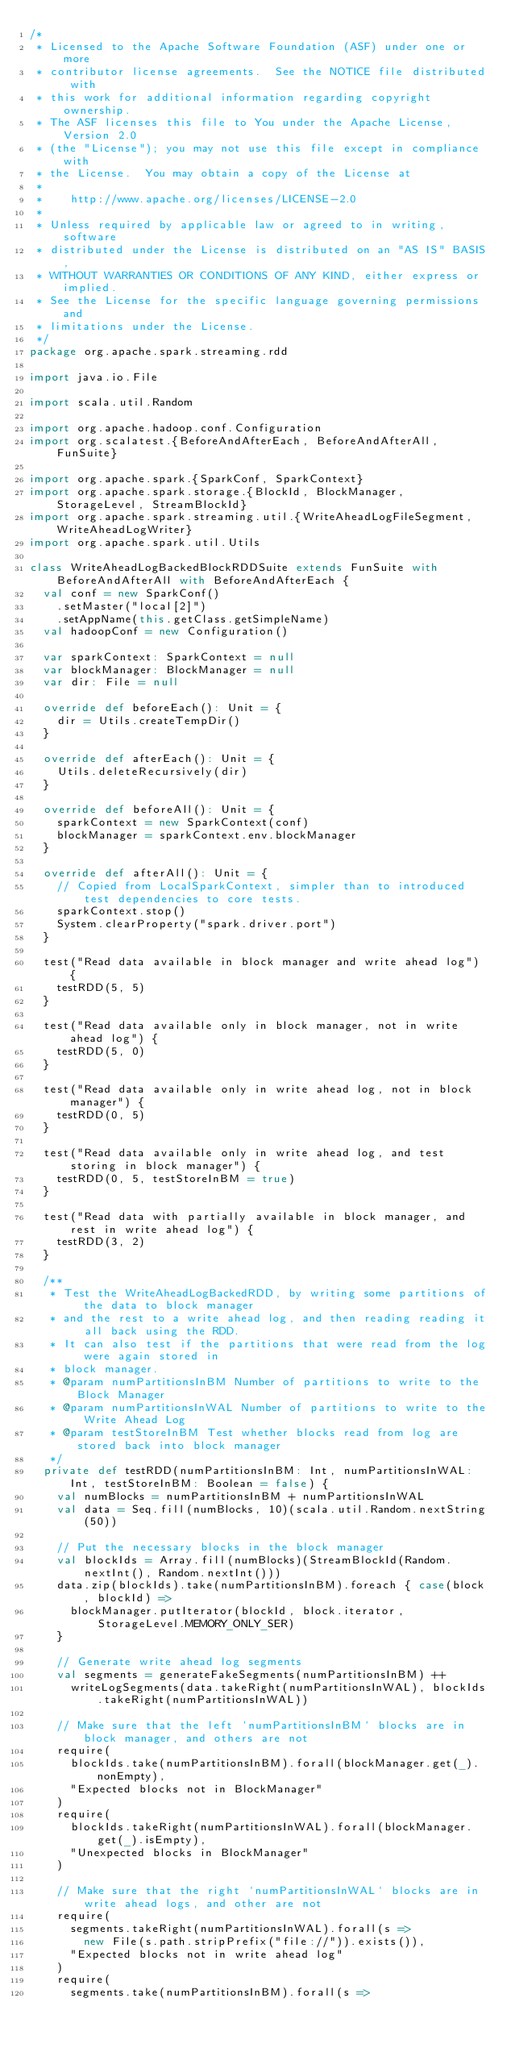Convert code to text. <code><loc_0><loc_0><loc_500><loc_500><_Scala_>/*
 * Licensed to the Apache Software Foundation (ASF) under one or more
 * contributor license agreements.  See the NOTICE file distributed with
 * this work for additional information regarding copyright ownership.
 * The ASF licenses this file to You under the Apache License, Version 2.0
 * (the "License"); you may not use this file except in compliance with
 * the License.  You may obtain a copy of the License at
 *
 *    http://www.apache.org/licenses/LICENSE-2.0
 *
 * Unless required by applicable law or agreed to in writing, software
 * distributed under the License is distributed on an "AS IS" BASIS,
 * WITHOUT WARRANTIES OR CONDITIONS OF ANY KIND, either express or implied.
 * See the License for the specific language governing permissions and
 * limitations under the License.
 */
package org.apache.spark.streaming.rdd

import java.io.File

import scala.util.Random

import org.apache.hadoop.conf.Configuration
import org.scalatest.{BeforeAndAfterEach, BeforeAndAfterAll, FunSuite}

import org.apache.spark.{SparkConf, SparkContext}
import org.apache.spark.storage.{BlockId, BlockManager, StorageLevel, StreamBlockId}
import org.apache.spark.streaming.util.{WriteAheadLogFileSegment, WriteAheadLogWriter}
import org.apache.spark.util.Utils

class WriteAheadLogBackedBlockRDDSuite extends FunSuite with BeforeAndAfterAll with BeforeAndAfterEach {
  val conf = new SparkConf()
    .setMaster("local[2]")
    .setAppName(this.getClass.getSimpleName)
  val hadoopConf = new Configuration()

  var sparkContext: SparkContext = null
  var blockManager: BlockManager = null
  var dir: File = null

  override def beforeEach(): Unit = {
    dir = Utils.createTempDir()
  }

  override def afterEach(): Unit = {
    Utils.deleteRecursively(dir)
  }

  override def beforeAll(): Unit = {
    sparkContext = new SparkContext(conf)
    blockManager = sparkContext.env.blockManager
  }

  override def afterAll(): Unit = {
    // Copied from LocalSparkContext, simpler than to introduced test dependencies to core tests.
    sparkContext.stop()
    System.clearProperty("spark.driver.port")
  }

  test("Read data available in block manager and write ahead log") {
    testRDD(5, 5)
  }

  test("Read data available only in block manager, not in write ahead log") {
    testRDD(5, 0)
  }

  test("Read data available only in write ahead log, not in block manager") {
    testRDD(0, 5)
  }

  test("Read data available only in write ahead log, and test storing in block manager") {
    testRDD(0, 5, testStoreInBM = true)
  }

  test("Read data with partially available in block manager, and rest in write ahead log") {
    testRDD(3, 2)
  }

  /**
   * Test the WriteAheadLogBackedRDD, by writing some partitions of the data to block manager
   * and the rest to a write ahead log, and then reading reading it all back using the RDD.
   * It can also test if the partitions that were read from the log were again stored in
   * block manager.
   * @param numPartitionsInBM Number of partitions to write to the Block Manager
   * @param numPartitionsInWAL Number of partitions to write to the Write Ahead Log
   * @param testStoreInBM Test whether blocks read from log are stored back into block manager
   */
  private def testRDD(numPartitionsInBM: Int, numPartitionsInWAL: Int, testStoreInBM: Boolean = false) {
    val numBlocks = numPartitionsInBM + numPartitionsInWAL
    val data = Seq.fill(numBlocks, 10)(scala.util.Random.nextString(50))

    // Put the necessary blocks in the block manager
    val blockIds = Array.fill(numBlocks)(StreamBlockId(Random.nextInt(), Random.nextInt()))
    data.zip(blockIds).take(numPartitionsInBM).foreach { case(block, blockId) =>
      blockManager.putIterator(blockId, block.iterator, StorageLevel.MEMORY_ONLY_SER)
    }

    // Generate write ahead log segments
    val segments = generateFakeSegments(numPartitionsInBM) ++
      writeLogSegments(data.takeRight(numPartitionsInWAL), blockIds.takeRight(numPartitionsInWAL))

    // Make sure that the left `numPartitionsInBM` blocks are in block manager, and others are not
    require(
      blockIds.take(numPartitionsInBM).forall(blockManager.get(_).nonEmpty),
      "Expected blocks not in BlockManager"
    )
    require(
      blockIds.takeRight(numPartitionsInWAL).forall(blockManager.get(_).isEmpty),
      "Unexpected blocks in BlockManager"
    )

    // Make sure that the right `numPartitionsInWAL` blocks are in write ahead logs, and other are not
    require(
      segments.takeRight(numPartitionsInWAL).forall(s =>
        new File(s.path.stripPrefix("file://")).exists()),
      "Expected blocks not in write ahead log"
    )
    require(
      segments.take(numPartitionsInBM).forall(s =></code> 